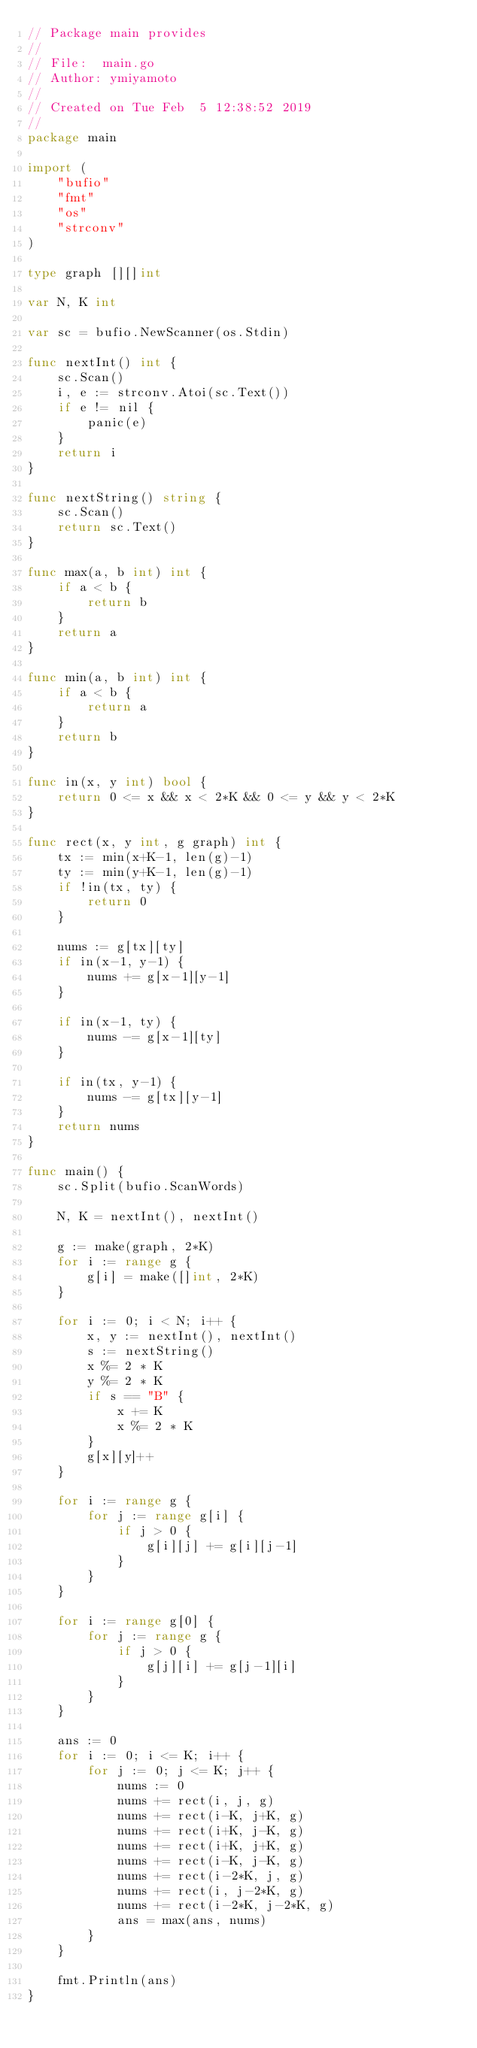<code> <loc_0><loc_0><loc_500><loc_500><_Go_>// Package main provides
//
// File:  main.go
// Author: ymiyamoto
//
// Created on Tue Feb  5 12:38:52 2019
//
package main

import (
	"bufio"
	"fmt"
	"os"
	"strconv"
)

type graph [][]int

var N, K int

var sc = bufio.NewScanner(os.Stdin)

func nextInt() int {
	sc.Scan()
	i, e := strconv.Atoi(sc.Text())
	if e != nil {
		panic(e)
	}
	return i
}

func nextString() string {
	sc.Scan()
	return sc.Text()
}

func max(a, b int) int {
	if a < b {
		return b
	}
	return a
}

func min(a, b int) int {
	if a < b {
		return a
	}
	return b
}

func in(x, y int) bool {
	return 0 <= x && x < 2*K && 0 <= y && y < 2*K
}

func rect(x, y int, g graph) int {
	tx := min(x+K-1, len(g)-1)
	ty := min(y+K-1, len(g)-1)
	if !in(tx, ty) {
		return 0
	}

	nums := g[tx][ty]
	if in(x-1, y-1) {
		nums += g[x-1][y-1]
	}

	if in(x-1, ty) {
		nums -= g[x-1][ty]
	}

	if in(tx, y-1) {
		nums -= g[tx][y-1]
	}
	return nums
}

func main() {
	sc.Split(bufio.ScanWords)

	N, K = nextInt(), nextInt()

	g := make(graph, 2*K)
	for i := range g {
		g[i] = make([]int, 2*K)
	}

	for i := 0; i < N; i++ {
		x, y := nextInt(), nextInt()
		s := nextString()
		x %= 2 * K
		y %= 2 * K
		if s == "B" {
			x += K
			x %= 2 * K
		}
		g[x][y]++
	}

	for i := range g {
		for j := range g[i] {
			if j > 0 {
				g[i][j] += g[i][j-1]
			}
		}
	}

	for i := range g[0] {
		for j := range g {
			if j > 0 {
				g[j][i] += g[j-1][i]
			}
		}
	}

	ans := 0
	for i := 0; i <= K; i++ {
		for j := 0; j <= K; j++ {
			nums := 0
			nums += rect(i, j, g)
			nums += rect(i-K, j+K, g)
			nums += rect(i+K, j-K, g)
			nums += rect(i+K, j+K, g)
			nums += rect(i-K, j-K, g)
			nums += rect(i-2*K, j, g)
			nums += rect(i, j-2*K, g)
			nums += rect(i-2*K, j-2*K, g)
			ans = max(ans, nums)
		}
	}

	fmt.Println(ans)
}
</code> 